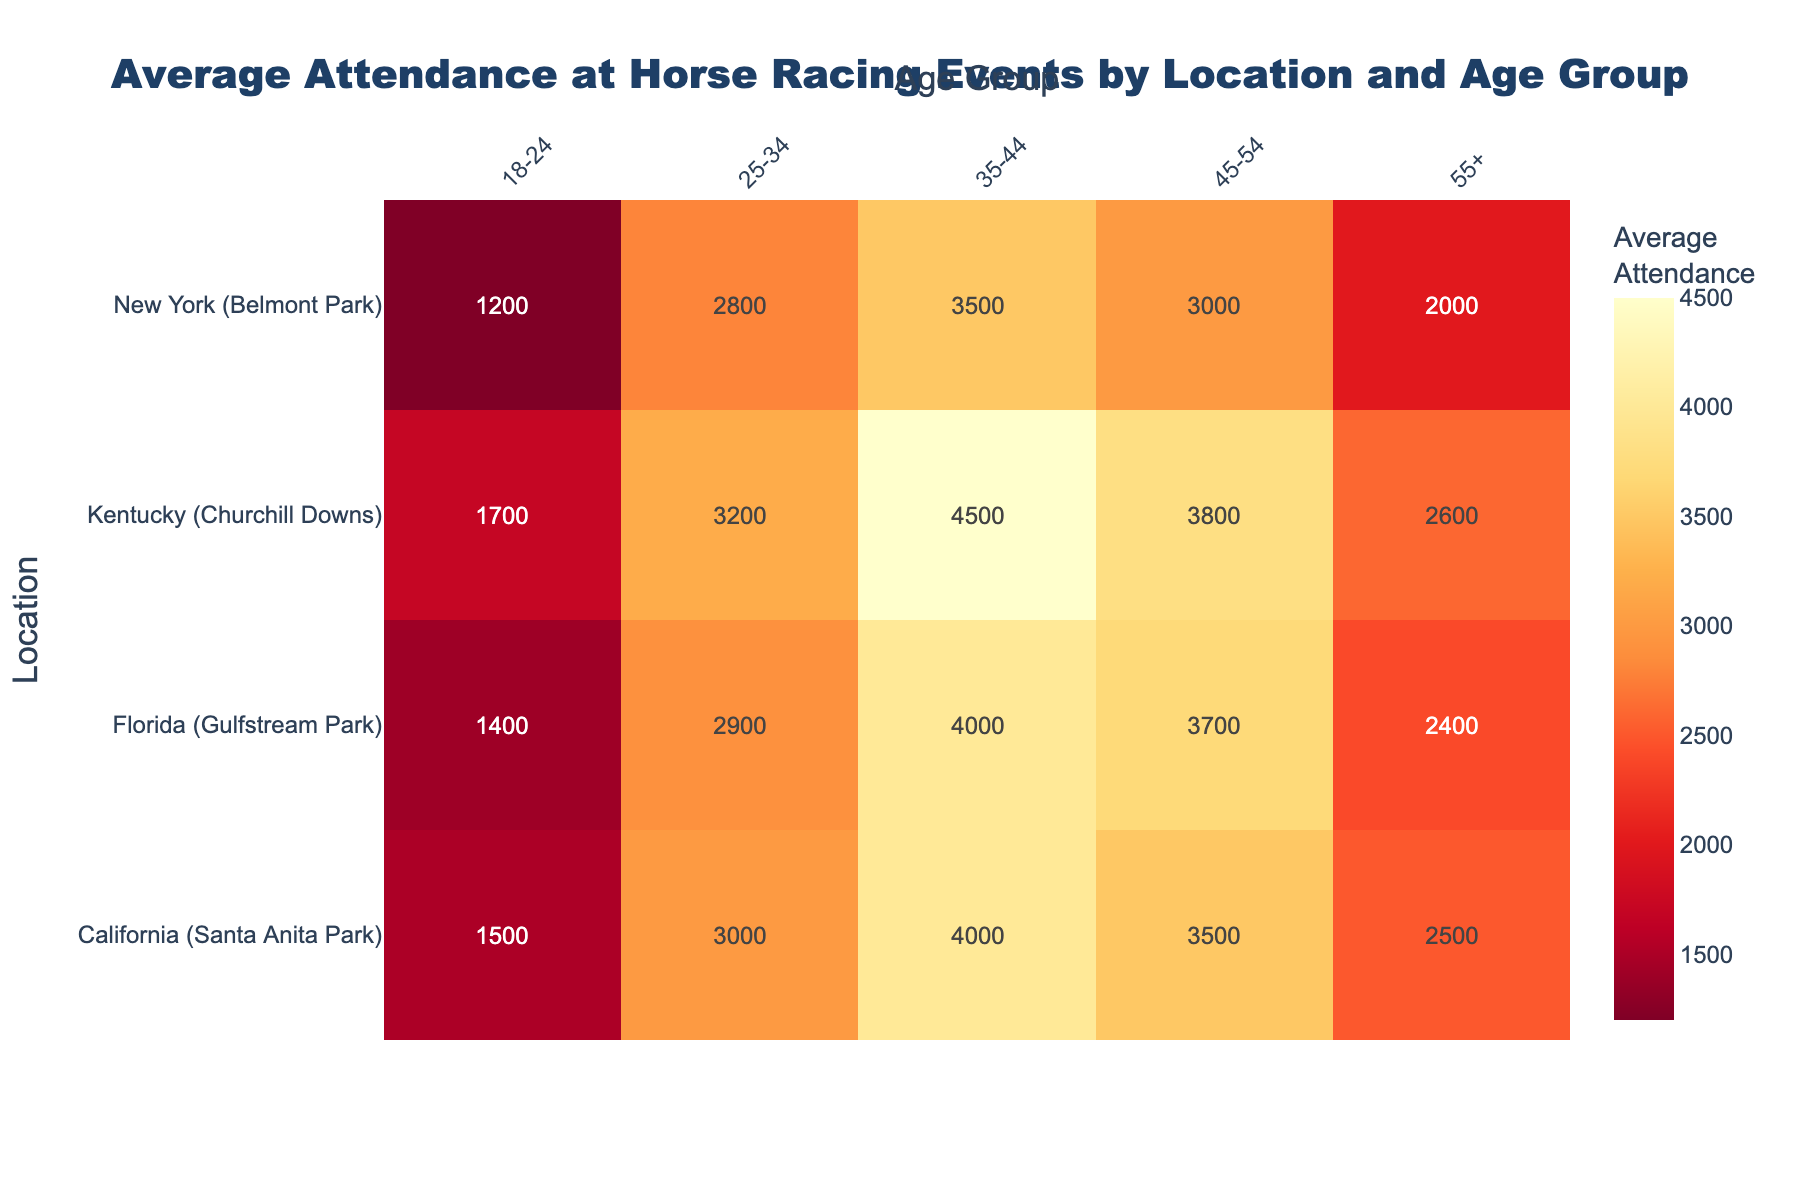What is the title of the heatmap? The title is displayed at the top of the heatmap and summarizes the content of the visualization. It reads, "Average Attendance at Horse Racing Events by Location and Age Group".
Answer: Average Attendance at Horse Racing Events by Location and Age Group Which location has the highest average attendance in the age group 35-44? Look at the column corresponding to the 35-44 age group and identify the highest value. The highest value in this column is 4500, which corresponds to Kentucky (Churchill Downs).
Answer: Kentucky (Churchill Downs) What is the sum of the average attendance for the 25-34 age group across all locations? Add up the values for the 25-34 age group across all rows: 3000 (California) + 3200 (Kentucky) + 2800 (New York) + 2900 (Florida) = 11,900.
Answer: 11,900 Which age group has the lowest average attendance at New York (Belmont Park)? Look at the rows for New York (Belmont Park) and identify the lowest value. The lowest value is 1200, which corresponds to the 18-24 age group.
Answer: 18-24 Does Florida (Gulfstream Park) have a higher or lower average attendance for the 45-54 age group compared to California (Santa Anita Park)? Compare the values in the 45-54 age group for Florida and California. Florida has 3700 and California has 3500. Therefore, Florida has a higher average attendance for this age group.
Answer: Higher Which location has the most balanced average attendance across all age groups? Examine the dispersion of the average attendance values for each location. The more balanced values would indicate less variability across age groups. Kentucky (Churchill Downs) seems to have consistently high values that do not vary greatly.
Answer: Kentucky (Churchill Downs) What is the average attendance for the oldest age group (55+) in all locations combined? Add up the values for the 55+ age group across all rows and divide by the number of locations: (2500 + 2600 + 2000 + 2400) / 4 = 9500 / 4 = 2375.
Answer: 2375 Which age group shows the highest variability in attendance across all locations? Determine the range (difference between the highest and lowest values) for each age group. The 35-44 age group has a range of 4500 (4500 - 3500), indicating it has the highest variability.
Answer: 35-44 What is the difference in average attendance between the youngest (18-24) and the oldest (55+) age groups for Kentucky (Churchill Downs)? Subtract the average attendance of the 55+ age group from the 18-24 age group for Kentucky: 1700 (18-24) - 2600 (55+) = -900.
Answer: -900 What is the median average attendance for the age group 45-54 across all locations? To find the median, list the attendance values for the 45-54 age group and identify the middle value: 3000, 3500, 3700, 3800. The median is the average of the two middle values: (3500 + 3700) / 2 = 3600.
Answer: 3600 